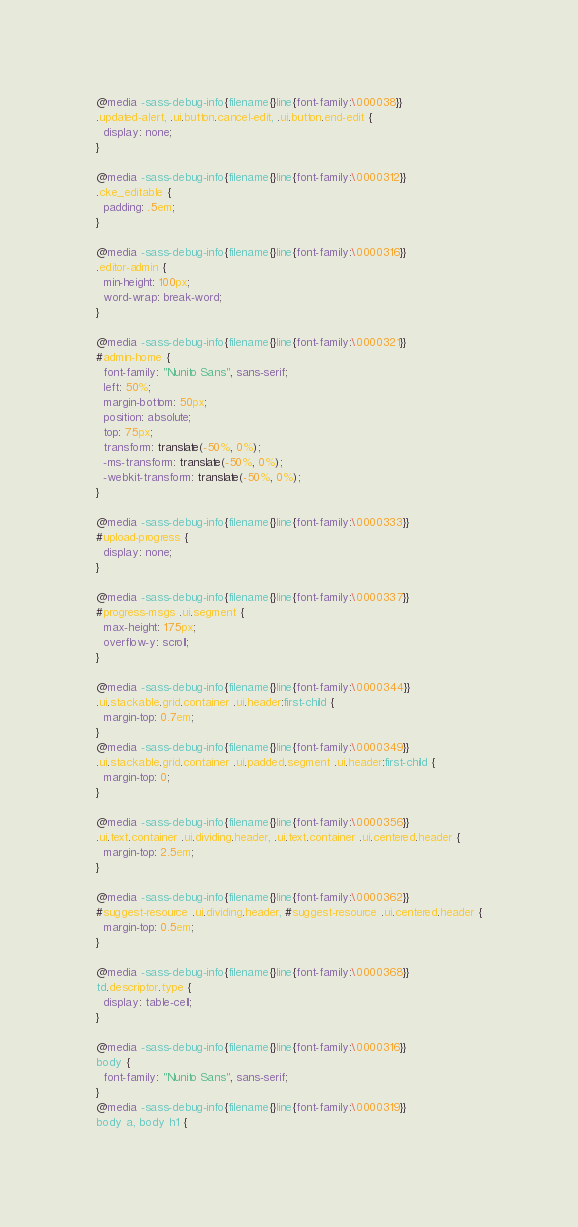<code> <loc_0><loc_0><loc_500><loc_500><_CSS_>@media -sass-debug-info{filename{}line{font-family:\000038}}
.updated-alert, .ui.button.cancel-edit, .ui.button.end-edit {
  display: none;
}

@media -sass-debug-info{filename{}line{font-family:\0000312}}
.cke_editable {
  padding: .5em;
}

@media -sass-debug-info{filename{}line{font-family:\0000316}}
.editor-admin {
  min-height: 100px;
  word-wrap: break-word;
}

@media -sass-debug-info{filename{}line{font-family:\0000321}}
#admin-home {
  font-family: "Nunito Sans", sans-serif;
  left: 50%;
  margin-bottom: 50px;
  position: absolute;
  top: 75px;
  transform: translate(-50%, 0%);
  -ms-transform: translate(-50%, 0%);
  -webkit-transform: translate(-50%, 0%);
}

@media -sass-debug-info{filename{}line{font-family:\0000333}}
#upload-progress {
  display: none;
}

@media -sass-debug-info{filename{}line{font-family:\0000337}}
#progress-msgs .ui.segment {
  max-height: 175px;
  overflow-y: scroll;
}

@media -sass-debug-info{filename{}line{font-family:\0000344}}
.ui.stackable.grid.container .ui.header:first-child {
  margin-top: 0.7em;
}
@media -sass-debug-info{filename{}line{font-family:\0000349}}
.ui.stackable.grid.container .ui.padded.segment .ui.header:first-child {
  margin-top: 0;
}

@media -sass-debug-info{filename{}line{font-family:\0000356}}
.ui.text.container .ui.dividing.header, .ui.text.container .ui.centered.header {
  margin-top: 2.5em;
}

@media -sass-debug-info{filename{}line{font-family:\0000362}}
#suggest-resource .ui.dividing.header, #suggest-resource .ui.centered.header {
  margin-top: 0.5em;
}

@media -sass-debug-info{filename{}line{font-family:\0000368}}
td.descriptor.type {
  display: table-cell;
}

@media -sass-debug-info{filename{}line{font-family:\0000316}}
body {
  font-family: "Nunito Sans", sans-serif;
}
@media -sass-debug-info{filename{}line{font-family:\0000319}}
body a, body h1 {</code> 